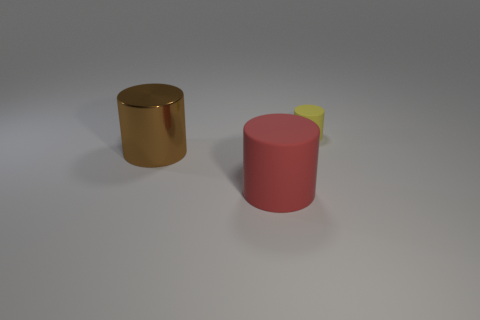Add 3 yellow matte cylinders. How many objects exist? 6 Add 2 small things. How many small things are left? 3 Add 3 tiny rubber cylinders. How many tiny rubber cylinders exist? 4 Subtract 0 gray blocks. How many objects are left? 3 Subtract all small yellow matte cylinders. Subtract all small blue cubes. How many objects are left? 2 